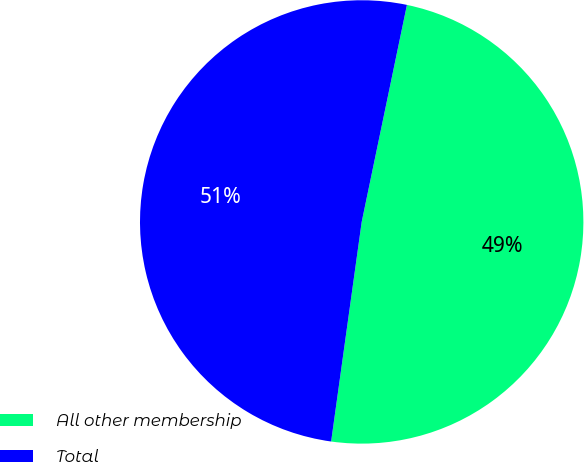Convert chart to OTSL. <chart><loc_0><loc_0><loc_500><loc_500><pie_chart><fcel>All other membership<fcel>Total<nl><fcel>48.93%<fcel>51.07%<nl></chart> 